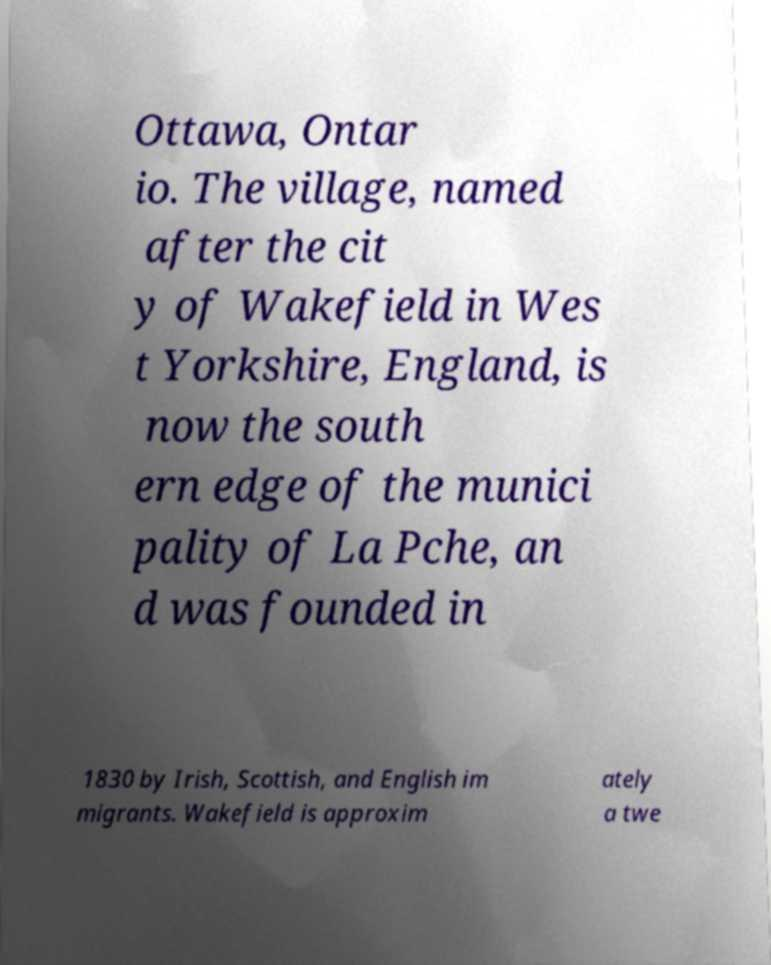Could you extract and type out the text from this image? Ottawa, Ontar io. The village, named after the cit y of Wakefield in Wes t Yorkshire, England, is now the south ern edge of the munici pality of La Pche, an d was founded in 1830 by Irish, Scottish, and English im migrants. Wakefield is approxim ately a twe 